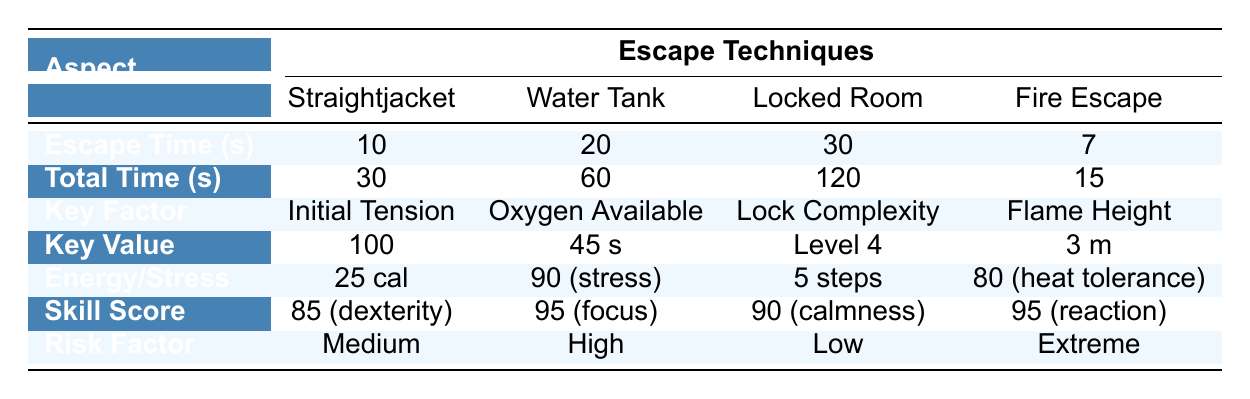What is the successful escape time for the Water Tank Escape? The escape time for the Water Tank Escape is listed under the "Escape Time (s)" row for that technique. Referring to the table, the successful escape time for the Water Tank Escape is 20 seconds.
Answer: 20 seconds What is the total time spent on the Locked Escape Room? The total time spent on the Locked Escape Room is indicated in the "Total Time (s)" row for that technique. According to the table, it shows a total time of 120 seconds.
Answer: 120 seconds Which technique has the highest risk factor? By checking the "Risk Factor" row for each escape technique, we can see the values: Medium, High, Low, and Extreme. The highest among these is Extreme, associated with the Fire Escape technique.
Answer: Fire Escape What is the average successful escape time across all techniques? To find the average successful escape time, we first need to sum the successful escape times: 10 + 20 + 30 + 7 = 67. Then we divide by the number of techniques (4): 67 / 4 = 16.75 seconds, which represents the average.
Answer: 16.75 seconds Is the dexterity score for the Straightjacket Escape higher than the calmness under pressure score for the Locked Escape Room? By looking at the provided scores, the dexterity score for the Straightjacket Escape is 85, while the calmness under pressure score for the Locked Escape Room is 90. Since 85 is less than 90, the statement is false.
Answer: No What is the total energy expenditure for the Straightjacket Escape and the Water Tank Escape combined? We need to add the energy expenditures for both techniques: For the Straightjacket Escape it is 25 calories and for the Water Tank Escape we see that there is no calories listed in the table. Thus only the Straightjacket Escape counts, leading to a total of 25 calories.
Answer: 25 calories What tools are used in the Locked Escape Room? The tools used in the Locked Escape Room are specified in the "tools_used" section under mechanics. The table shows they include a lock pick and a screwdriver.
Answer: Lock pick, screwdriver What is the difference in stress level between the Water Tank Escape and the Locked Escape Room? The stress level for the Water Tank Escape is indicated as 90, and for the Locked Escape Room, there is no specific stress level provided. We assume "environment interference" is low and does not represent a number compared. However, the comparison indicates that the stress for the Water Tank is higher while Locked Escape is said to have low interference resulting in lower stress.
Answer: Water Tank Escape has higher stress level What is the highest possible score for mental focus among the escape techniques? The highest mental focus score can be found under "mental_focus_score" for the Water Tank Escape, which indicates a score of 95. This is the highest score compared to others in the table.
Answer: 95 